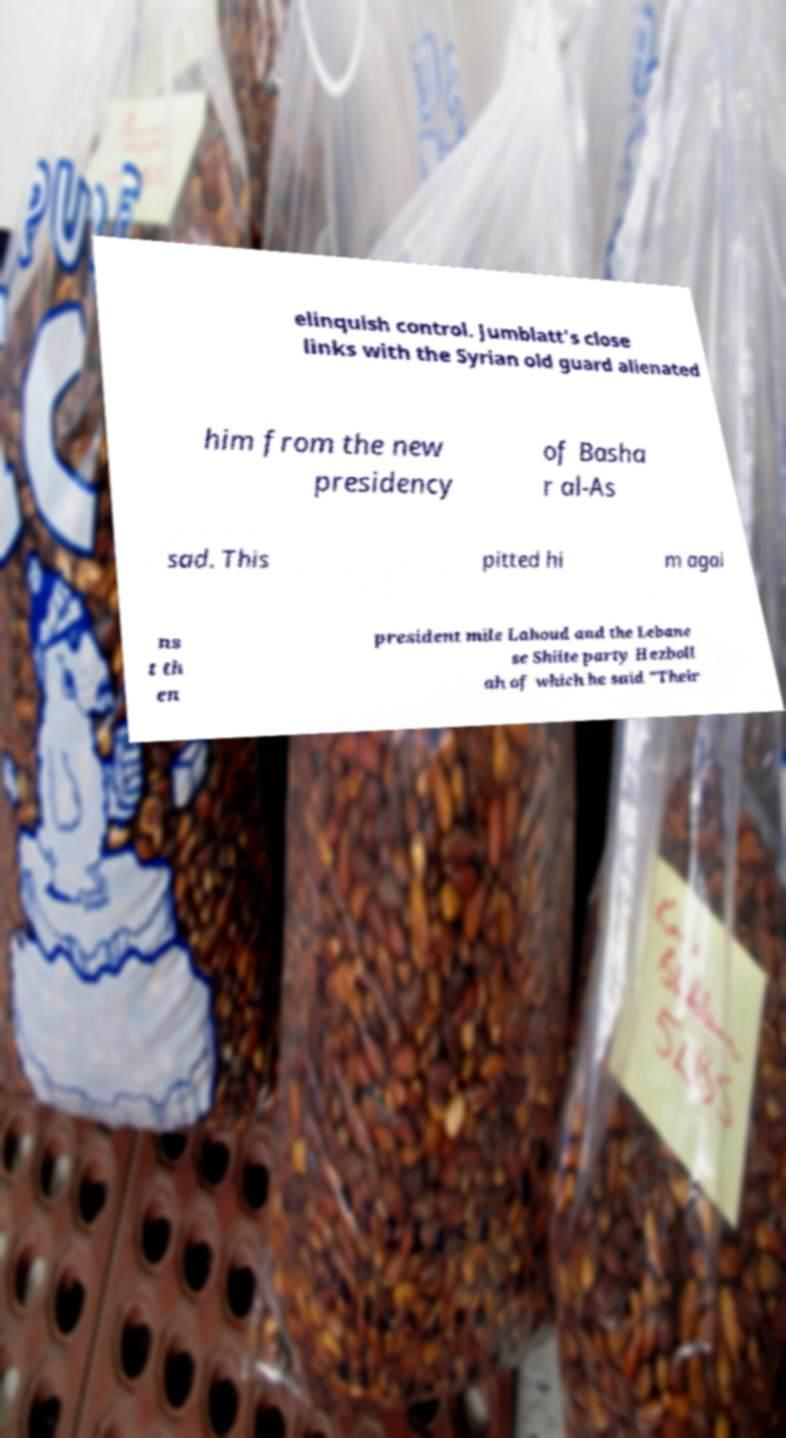What messages or text are displayed in this image? I need them in a readable, typed format. elinquish control. Jumblatt's close links with the Syrian old guard alienated him from the new presidency of Basha r al-As sad. This pitted hi m agai ns t th en president mile Lahoud and the Lebane se Shiite party Hezboll ah of which he said "Their 